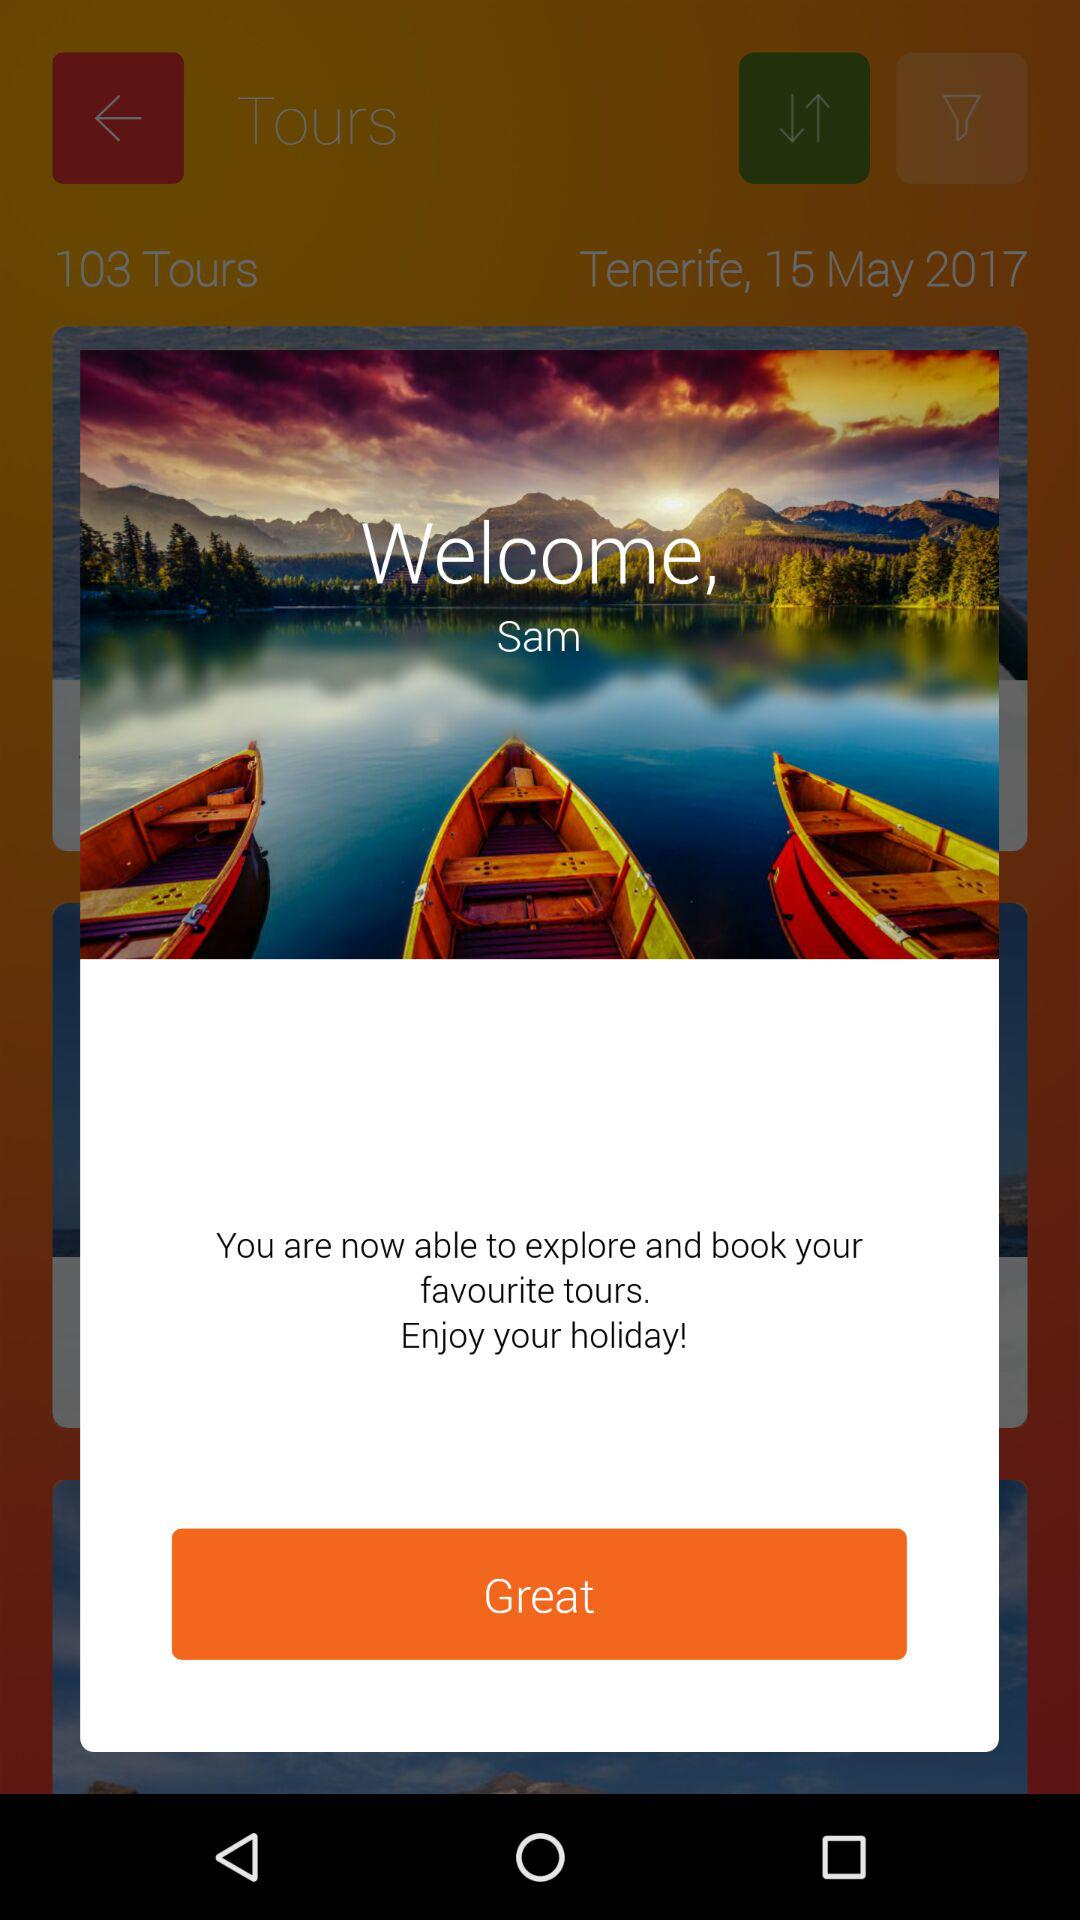What is the user name? The user name is Sam. 